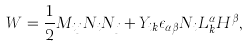Convert formula to latex. <formula><loc_0><loc_0><loc_500><loc_500>W = \frac { 1 } { 2 } M _ { i j } N _ { i } N _ { j } + Y _ { i k } \epsilon _ { \alpha \beta } N _ { i } L _ { k } ^ { \alpha } H ^ { \beta } ,</formula> 